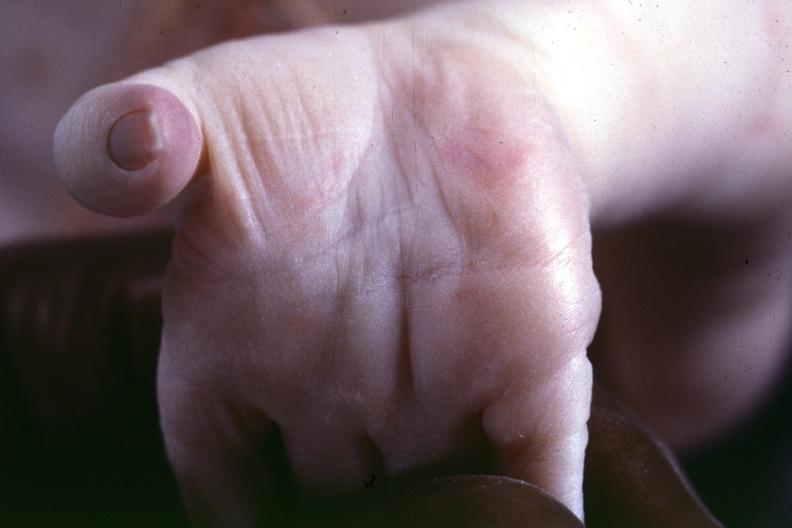s hand present?
Answer the question using a single word or phrase. Yes 